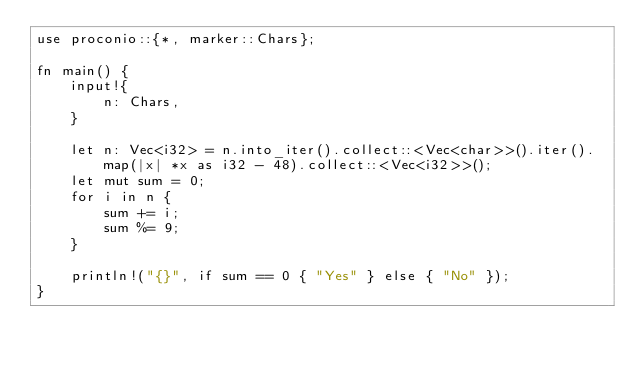<code> <loc_0><loc_0><loc_500><loc_500><_Rust_>use proconio::{*, marker::Chars};

fn main() {
    input!{
        n: Chars,
    }

    let n: Vec<i32> = n.into_iter().collect::<Vec<char>>().iter().map(|x| *x as i32 - 48).collect::<Vec<i32>>();
    let mut sum = 0;
    for i in n {
        sum += i;
        sum %= 9;
    }

    println!("{}", if sum == 0 { "Yes" } else { "No" });
}
</code> 